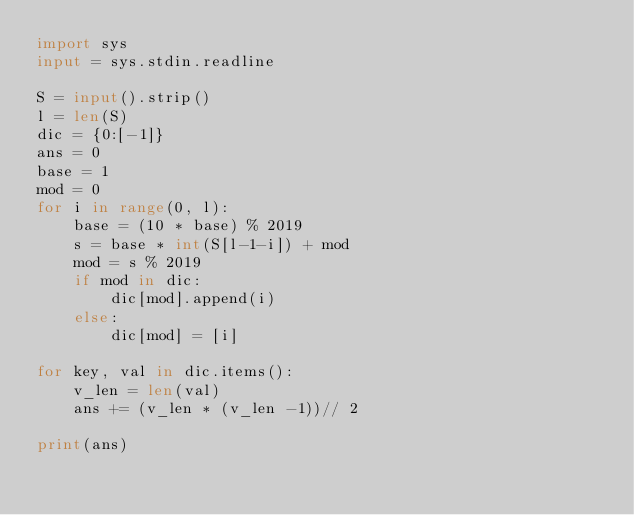Convert code to text. <code><loc_0><loc_0><loc_500><loc_500><_Python_>import sys
input = sys.stdin.readline

S = input().strip()
l = len(S)
dic = {0:[-1]}
ans = 0
base = 1
mod = 0
for i in range(0, l):
    base = (10 * base) % 2019
    s = base * int(S[l-1-i]) + mod
    mod = s % 2019
    if mod in dic:
        dic[mod].append(i)
    else:
        dic[mod] = [i]

for key, val in dic.items():
    v_len = len(val)
    ans += (v_len * (v_len -1))// 2

print(ans)

</code> 